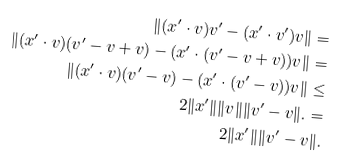<formula> <loc_0><loc_0><loc_500><loc_500>\| { ( x ^ { \prime } \cdot v ) v ^ { \prime } - ( x ^ { \prime } \cdot v ^ { \prime } ) v } \| = \\ \| ( x ^ { \prime } \cdot v ) ( v ^ { \prime } - v + v ) - ( x ^ { \prime } \cdot ( v ^ { \prime } - v + v ) ) v \| = \\ \| ( x ^ { \prime } \cdot v ) ( v ^ { \prime } - v ) - ( x ^ { \prime } \cdot ( v ^ { \prime } - v ) ) v \| \leq \\ 2 \| x ^ { \prime } \| \| v \| \| v ^ { \prime } - v \| . = \\ 2 \| x ^ { \prime } \| \| v ^ { \prime } - v \| .</formula> 